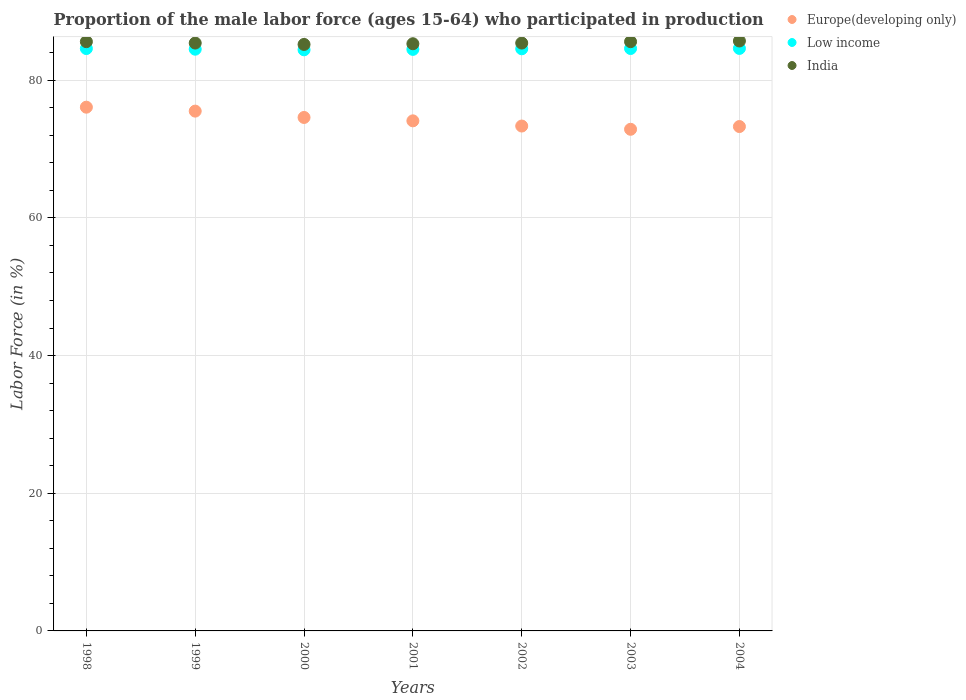How many different coloured dotlines are there?
Offer a terse response. 3. Is the number of dotlines equal to the number of legend labels?
Your answer should be very brief. Yes. What is the proportion of the male labor force who participated in production in India in 2001?
Offer a very short reply. 85.3. Across all years, what is the maximum proportion of the male labor force who participated in production in Low income?
Provide a short and direct response. 84.62. Across all years, what is the minimum proportion of the male labor force who participated in production in Low income?
Your answer should be very brief. 84.42. In which year was the proportion of the male labor force who participated in production in India maximum?
Make the answer very short. 2004. In which year was the proportion of the male labor force who participated in production in India minimum?
Offer a very short reply. 2000. What is the total proportion of the male labor force who participated in production in Low income in the graph?
Offer a terse response. 591.8. What is the difference between the proportion of the male labor force who participated in production in Low income in 2000 and that in 2004?
Your answer should be very brief. -0.2. What is the difference between the proportion of the male labor force who participated in production in India in 1999 and the proportion of the male labor force who participated in production in Low income in 2001?
Make the answer very short. 0.92. What is the average proportion of the male labor force who participated in production in Europe(developing only) per year?
Make the answer very short. 74.25. In the year 2004, what is the difference between the proportion of the male labor force who participated in production in India and proportion of the male labor force who participated in production in Europe(developing only)?
Provide a succinct answer. 12.43. In how many years, is the proportion of the male labor force who participated in production in Europe(developing only) greater than 20 %?
Offer a very short reply. 7. What is the ratio of the proportion of the male labor force who participated in production in Europe(developing only) in 1999 to that in 2003?
Make the answer very short. 1.04. Is the proportion of the male labor force who participated in production in Low income in 1998 less than that in 2001?
Your response must be concise. No. Is the difference between the proportion of the male labor force who participated in production in India in 2002 and 2003 greater than the difference between the proportion of the male labor force who participated in production in Europe(developing only) in 2002 and 2003?
Give a very brief answer. No. What is the difference between the highest and the second highest proportion of the male labor force who participated in production in India?
Make the answer very short. 0.1. What is the difference between the highest and the lowest proportion of the male labor force who participated in production in Europe(developing only)?
Your answer should be compact. 3.21. Does the proportion of the male labor force who participated in production in India monotonically increase over the years?
Your answer should be very brief. No. Is the proportion of the male labor force who participated in production in Europe(developing only) strictly greater than the proportion of the male labor force who participated in production in Low income over the years?
Your response must be concise. No. How many dotlines are there?
Offer a terse response. 3. How many years are there in the graph?
Your response must be concise. 7. Are the values on the major ticks of Y-axis written in scientific E-notation?
Offer a terse response. No. Does the graph contain any zero values?
Ensure brevity in your answer.  No. Where does the legend appear in the graph?
Your answer should be very brief. Top right. How are the legend labels stacked?
Ensure brevity in your answer.  Vertical. What is the title of the graph?
Your response must be concise. Proportion of the male labor force (ages 15-64) who participated in production. Does "Tonga" appear as one of the legend labels in the graph?
Your answer should be compact. No. What is the label or title of the X-axis?
Provide a succinct answer. Years. What is the label or title of the Y-axis?
Ensure brevity in your answer.  Labor Force (in %). What is the Labor Force (in %) in Europe(developing only) in 1998?
Offer a terse response. 76.08. What is the Labor Force (in %) of Low income in 1998?
Your response must be concise. 84.6. What is the Labor Force (in %) of India in 1998?
Your response must be concise. 85.6. What is the Labor Force (in %) in Europe(developing only) in 1999?
Ensure brevity in your answer.  75.51. What is the Labor Force (in %) of Low income in 1999?
Give a very brief answer. 84.51. What is the Labor Force (in %) in India in 1999?
Offer a very short reply. 85.4. What is the Labor Force (in %) of Europe(developing only) in 2000?
Ensure brevity in your answer.  74.59. What is the Labor Force (in %) of Low income in 2000?
Your response must be concise. 84.42. What is the Labor Force (in %) in India in 2000?
Offer a very short reply. 85.2. What is the Labor Force (in %) in Europe(developing only) in 2001?
Provide a short and direct response. 74.1. What is the Labor Force (in %) in Low income in 2001?
Make the answer very short. 84.48. What is the Labor Force (in %) of India in 2001?
Give a very brief answer. 85.3. What is the Labor Force (in %) in Europe(developing only) in 2002?
Your response must be concise. 73.34. What is the Labor Force (in %) in Low income in 2002?
Your answer should be very brief. 84.57. What is the Labor Force (in %) in India in 2002?
Your answer should be very brief. 85.4. What is the Labor Force (in %) of Europe(developing only) in 2003?
Make the answer very short. 72.87. What is the Labor Force (in %) of Low income in 2003?
Provide a succinct answer. 84.61. What is the Labor Force (in %) of India in 2003?
Offer a terse response. 85.6. What is the Labor Force (in %) of Europe(developing only) in 2004?
Your answer should be very brief. 73.27. What is the Labor Force (in %) of Low income in 2004?
Offer a terse response. 84.62. What is the Labor Force (in %) of India in 2004?
Ensure brevity in your answer.  85.7. Across all years, what is the maximum Labor Force (in %) in Europe(developing only)?
Keep it short and to the point. 76.08. Across all years, what is the maximum Labor Force (in %) of Low income?
Keep it short and to the point. 84.62. Across all years, what is the maximum Labor Force (in %) of India?
Make the answer very short. 85.7. Across all years, what is the minimum Labor Force (in %) in Europe(developing only)?
Keep it short and to the point. 72.87. Across all years, what is the minimum Labor Force (in %) of Low income?
Offer a very short reply. 84.42. Across all years, what is the minimum Labor Force (in %) in India?
Your answer should be compact. 85.2. What is the total Labor Force (in %) in Europe(developing only) in the graph?
Your answer should be very brief. 519.78. What is the total Labor Force (in %) in Low income in the graph?
Your response must be concise. 591.8. What is the total Labor Force (in %) in India in the graph?
Provide a succinct answer. 598.2. What is the difference between the Labor Force (in %) in Europe(developing only) in 1998 and that in 1999?
Ensure brevity in your answer.  0.57. What is the difference between the Labor Force (in %) in Low income in 1998 and that in 1999?
Make the answer very short. 0.09. What is the difference between the Labor Force (in %) of India in 1998 and that in 1999?
Provide a succinct answer. 0.2. What is the difference between the Labor Force (in %) of Europe(developing only) in 1998 and that in 2000?
Provide a short and direct response. 1.49. What is the difference between the Labor Force (in %) in Low income in 1998 and that in 2000?
Provide a short and direct response. 0.19. What is the difference between the Labor Force (in %) of Europe(developing only) in 1998 and that in 2001?
Offer a terse response. 1.98. What is the difference between the Labor Force (in %) of Low income in 1998 and that in 2001?
Provide a short and direct response. 0.12. What is the difference between the Labor Force (in %) in Europe(developing only) in 1998 and that in 2002?
Provide a succinct answer. 2.74. What is the difference between the Labor Force (in %) of Low income in 1998 and that in 2002?
Make the answer very short. 0.04. What is the difference between the Labor Force (in %) in India in 1998 and that in 2002?
Your answer should be compact. 0.2. What is the difference between the Labor Force (in %) of Europe(developing only) in 1998 and that in 2003?
Give a very brief answer. 3.21. What is the difference between the Labor Force (in %) in Low income in 1998 and that in 2003?
Your response must be concise. -0.01. What is the difference between the Labor Force (in %) in India in 1998 and that in 2003?
Your response must be concise. 0. What is the difference between the Labor Force (in %) of Europe(developing only) in 1998 and that in 2004?
Give a very brief answer. 2.81. What is the difference between the Labor Force (in %) in Low income in 1998 and that in 2004?
Provide a short and direct response. -0.02. What is the difference between the Labor Force (in %) of Europe(developing only) in 1999 and that in 2000?
Your answer should be compact. 0.92. What is the difference between the Labor Force (in %) in Low income in 1999 and that in 2000?
Your answer should be compact. 0.09. What is the difference between the Labor Force (in %) of Europe(developing only) in 1999 and that in 2001?
Your response must be concise. 1.41. What is the difference between the Labor Force (in %) of Low income in 1999 and that in 2001?
Keep it short and to the point. 0.03. What is the difference between the Labor Force (in %) in India in 1999 and that in 2001?
Keep it short and to the point. 0.1. What is the difference between the Labor Force (in %) of Europe(developing only) in 1999 and that in 2002?
Offer a terse response. 2.17. What is the difference between the Labor Force (in %) of Low income in 1999 and that in 2002?
Offer a terse response. -0.06. What is the difference between the Labor Force (in %) of India in 1999 and that in 2002?
Offer a very short reply. 0. What is the difference between the Labor Force (in %) of Europe(developing only) in 1999 and that in 2003?
Keep it short and to the point. 2.64. What is the difference between the Labor Force (in %) of Low income in 1999 and that in 2003?
Ensure brevity in your answer.  -0.1. What is the difference between the Labor Force (in %) of India in 1999 and that in 2003?
Provide a succinct answer. -0.2. What is the difference between the Labor Force (in %) of Europe(developing only) in 1999 and that in 2004?
Offer a very short reply. 2.24. What is the difference between the Labor Force (in %) in Low income in 1999 and that in 2004?
Make the answer very short. -0.11. What is the difference between the Labor Force (in %) in Europe(developing only) in 2000 and that in 2001?
Ensure brevity in your answer.  0.49. What is the difference between the Labor Force (in %) of Low income in 2000 and that in 2001?
Your response must be concise. -0.06. What is the difference between the Labor Force (in %) in Europe(developing only) in 2000 and that in 2002?
Provide a short and direct response. 1.25. What is the difference between the Labor Force (in %) of Low income in 2000 and that in 2002?
Provide a short and direct response. -0.15. What is the difference between the Labor Force (in %) of India in 2000 and that in 2002?
Your answer should be very brief. -0.2. What is the difference between the Labor Force (in %) of Europe(developing only) in 2000 and that in 2003?
Make the answer very short. 1.72. What is the difference between the Labor Force (in %) in Low income in 2000 and that in 2003?
Provide a succinct answer. -0.19. What is the difference between the Labor Force (in %) in India in 2000 and that in 2003?
Make the answer very short. -0.4. What is the difference between the Labor Force (in %) in Europe(developing only) in 2000 and that in 2004?
Your response must be concise. 1.32. What is the difference between the Labor Force (in %) of Low income in 2000 and that in 2004?
Offer a very short reply. -0.2. What is the difference between the Labor Force (in %) of India in 2000 and that in 2004?
Your answer should be very brief. -0.5. What is the difference between the Labor Force (in %) of Europe(developing only) in 2001 and that in 2002?
Make the answer very short. 0.75. What is the difference between the Labor Force (in %) in Low income in 2001 and that in 2002?
Make the answer very short. -0.09. What is the difference between the Labor Force (in %) in India in 2001 and that in 2002?
Ensure brevity in your answer.  -0.1. What is the difference between the Labor Force (in %) of Europe(developing only) in 2001 and that in 2003?
Give a very brief answer. 1.23. What is the difference between the Labor Force (in %) of Low income in 2001 and that in 2003?
Provide a short and direct response. -0.13. What is the difference between the Labor Force (in %) of India in 2001 and that in 2003?
Your answer should be very brief. -0.3. What is the difference between the Labor Force (in %) in Europe(developing only) in 2001 and that in 2004?
Offer a terse response. 0.83. What is the difference between the Labor Force (in %) of Low income in 2001 and that in 2004?
Provide a short and direct response. -0.14. What is the difference between the Labor Force (in %) in Europe(developing only) in 2002 and that in 2003?
Make the answer very short. 0.47. What is the difference between the Labor Force (in %) in Low income in 2002 and that in 2003?
Keep it short and to the point. -0.04. What is the difference between the Labor Force (in %) of Europe(developing only) in 2002 and that in 2004?
Your answer should be very brief. 0.07. What is the difference between the Labor Force (in %) in Low income in 2002 and that in 2004?
Your response must be concise. -0.05. What is the difference between the Labor Force (in %) of India in 2002 and that in 2004?
Provide a succinct answer. -0.3. What is the difference between the Labor Force (in %) in Europe(developing only) in 2003 and that in 2004?
Offer a terse response. -0.4. What is the difference between the Labor Force (in %) in Low income in 2003 and that in 2004?
Your answer should be compact. -0.01. What is the difference between the Labor Force (in %) of Europe(developing only) in 1998 and the Labor Force (in %) of Low income in 1999?
Provide a short and direct response. -8.42. What is the difference between the Labor Force (in %) in Europe(developing only) in 1998 and the Labor Force (in %) in India in 1999?
Make the answer very short. -9.32. What is the difference between the Labor Force (in %) in Low income in 1998 and the Labor Force (in %) in India in 1999?
Ensure brevity in your answer.  -0.8. What is the difference between the Labor Force (in %) of Europe(developing only) in 1998 and the Labor Force (in %) of Low income in 2000?
Provide a short and direct response. -8.33. What is the difference between the Labor Force (in %) of Europe(developing only) in 1998 and the Labor Force (in %) of India in 2000?
Your answer should be compact. -9.12. What is the difference between the Labor Force (in %) in Low income in 1998 and the Labor Force (in %) in India in 2000?
Make the answer very short. -0.6. What is the difference between the Labor Force (in %) in Europe(developing only) in 1998 and the Labor Force (in %) in Low income in 2001?
Provide a succinct answer. -8.4. What is the difference between the Labor Force (in %) of Europe(developing only) in 1998 and the Labor Force (in %) of India in 2001?
Provide a succinct answer. -9.22. What is the difference between the Labor Force (in %) of Low income in 1998 and the Labor Force (in %) of India in 2001?
Your response must be concise. -0.7. What is the difference between the Labor Force (in %) in Europe(developing only) in 1998 and the Labor Force (in %) in Low income in 2002?
Provide a succinct answer. -8.48. What is the difference between the Labor Force (in %) in Europe(developing only) in 1998 and the Labor Force (in %) in India in 2002?
Provide a short and direct response. -9.32. What is the difference between the Labor Force (in %) of Low income in 1998 and the Labor Force (in %) of India in 2002?
Give a very brief answer. -0.8. What is the difference between the Labor Force (in %) of Europe(developing only) in 1998 and the Labor Force (in %) of Low income in 2003?
Provide a short and direct response. -8.52. What is the difference between the Labor Force (in %) of Europe(developing only) in 1998 and the Labor Force (in %) of India in 2003?
Your answer should be compact. -9.52. What is the difference between the Labor Force (in %) in Low income in 1998 and the Labor Force (in %) in India in 2003?
Your answer should be very brief. -1. What is the difference between the Labor Force (in %) in Europe(developing only) in 1998 and the Labor Force (in %) in Low income in 2004?
Offer a very short reply. -8.54. What is the difference between the Labor Force (in %) of Europe(developing only) in 1998 and the Labor Force (in %) of India in 2004?
Keep it short and to the point. -9.62. What is the difference between the Labor Force (in %) in Low income in 1998 and the Labor Force (in %) in India in 2004?
Ensure brevity in your answer.  -1.1. What is the difference between the Labor Force (in %) of Europe(developing only) in 1999 and the Labor Force (in %) of Low income in 2000?
Your answer should be compact. -8.9. What is the difference between the Labor Force (in %) of Europe(developing only) in 1999 and the Labor Force (in %) of India in 2000?
Ensure brevity in your answer.  -9.69. What is the difference between the Labor Force (in %) of Low income in 1999 and the Labor Force (in %) of India in 2000?
Your response must be concise. -0.69. What is the difference between the Labor Force (in %) in Europe(developing only) in 1999 and the Labor Force (in %) in Low income in 2001?
Your answer should be very brief. -8.97. What is the difference between the Labor Force (in %) in Europe(developing only) in 1999 and the Labor Force (in %) in India in 2001?
Provide a succinct answer. -9.79. What is the difference between the Labor Force (in %) in Low income in 1999 and the Labor Force (in %) in India in 2001?
Offer a very short reply. -0.79. What is the difference between the Labor Force (in %) in Europe(developing only) in 1999 and the Labor Force (in %) in Low income in 2002?
Provide a short and direct response. -9.05. What is the difference between the Labor Force (in %) of Europe(developing only) in 1999 and the Labor Force (in %) of India in 2002?
Provide a succinct answer. -9.89. What is the difference between the Labor Force (in %) in Low income in 1999 and the Labor Force (in %) in India in 2002?
Your answer should be very brief. -0.89. What is the difference between the Labor Force (in %) in Europe(developing only) in 1999 and the Labor Force (in %) in Low income in 2003?
Give a very brief answer. -9.1. What is the difference between the Labor Force (in %) in Europe(developing only) in 1999 and the Labor Force (in %) in India in 2003?
Offer a very short reply. -10.09. What is the difference between the Labor Force (in %) of Low income in 1999 and the Labor Force (in %) of India in 2003?
Your answer should be very brief. -1.09. What is the difference between the Labor Force (in %) of Europe(developing only) in 1999 and the Labor Force (in %) of Low income in 2004?
Offer a very short reply. -9.11. What is the difference between the Labor Force (in %) of Europe(developing only) in 1999 and the Labor Force (in %) of India in 2004?
Provide a short and direct response. -10.19. What is the difference between the Labor Force (in %) in Low income in 1999 and the Labor Force (in %) in India in 2004?
Keep it short and to the point. -1.19. What is the difference between the Labor Force (in %) in Europe(developing only) in 2000 and the Labor Force (in %) in Low income in 2001?
Offer a terse response. -9.89. What is the difference between the Labor Force (in %) of Europe(developing only) in 2000 and the Labor Force (in %) of India in 2001?
Your response must be concise. -10.71. What is the difference between the Labor Force (in %) in Low income in 2000 and the Labor Force (in %) in India in 2001?
Make the answer very short. -0.88. What is the difference between the Labor Force (in %) of Europe(developing only) in 2000 and the Labor Force (in %) of Low income in 2002?
Keep it short and to the point. -9.98. What is the difference between the Labor Force (in %) of Europe(developing only) in 2000 and the Labor Force (in %) of India in 2002?
Give a very brief answer. -10.81. What is the difference between the Labor Force (in %) of Low income in 2000 and the Labor Force (in %) of India in 2002?
Keep it short and to the point. -0.98. What is the difference between the Labor Force (in %) of Europe(developing only) in 2000 and the Labor Force (in %) of Low income in 2003?
Ensure brevity in your answer.  -10.02. What is the difference between the Labor Force (in %) in Europe(developing only) in 2000 and the Labor Force (in %) in India in 2003?
Provide a succinct answer. -11.01. What is the difference between the Labor Force (in %) of Low income in 2000 and the Labor Force (in %) of India in 2003?
Your answer should be compact. -1.18. What is the difference between the Labor Force (in %) of Europe(developing only) in 2000 and the Labor Force (in %) of Low income in 2004?
Offer a very short reply. -10.03. What is the difference between the Labor Force (in %) of Europe(developing only) in 2000 and the Labor Force (in %) of India in 2004?
Keep it short and to the point. -11.11. What is the difference between the Labor Force (in %) in Low income in 2000 and the Labor Force (in %) in India in 2004?
Keep it short and to the point. -1.28. What is the difference between the Labor Force (in %) in Europe(developing only) in 2001 and the Labor Force (in %) in Low income in 2002?
Give a very brief answer. -10.47. What is the difference between the Labor Force (in %) in Europe(developing only) in 2001 and the Labor Force (in %) in India in 2002?
Give a very brief answer. -11.3. What is the difference between the Labor Force (in %) in Low income in 2001 and the Labor Force (in %) in India in 2002?
Your response must be concise. -0.92. What is the difference between the Labor Force (in %) of Europe(developing only) in 2001 and the Labor Force (in %) of Low income in 2003?
Provide a short and direct response. -10.51. What is the difference between the Labor Force (in %) in Europe(developing only) in 2001 and the Labor Force (in %) in India in 2003?
Ensure brevity in your answer.  -11.5. What is the difference between the Labor Force (in %) in Low income in 2001 and the Labor Force (in %) in India in 2003?
Your response must be concise. -1.12. What is the difference between the Labor Force (in %) in Europe(developing only) in 2001 and the Labor Force (in %) in Low income in 2004?
Offer a very short reply. -10.52. What is the difference between the Labor Force (in %) of Europe(developing only) in 2001 and the Labor Force (in %) of India in 2004?
Provide a short and direct response. -11.6. What is the difference between the Labor Force (in %) in Low income in 2001 and the Labor Force (in %) in India in 2004?
Your answer should be very brief. -1.22. What is the difference between the Labor Force (in %) of Europe(developing only) in 2002 and the Labor Force (in %) of Low income in 2003?
Make the answer very short. -11.26. What is the difference between the Labor Force (in %) of Europe(developing only) in 2002 and the Labor Force (in %) of India in 2003?
Keep it short and to the point. -12.26. What is the difference between the Labor Force (in %) in Low income in 2002 and the Labor Force (in %) in India in 2003?
Provide a short and direct response. -1.03. What is the difference between the Labor Force (in %) of Europe(developing only) in 2002 and the Labor Force (in %) of Low income in 2004?
Your answer should be compact. -11.28. What is the difference between the Labor Force (in %) of Europe(developing only) in 2002 and the Labor Force (in %) of India in 2004?
Your answer should be compact. -12.36. What is the difference between the Labor Force (in %) of Low income in 2002 and the Labor Force (in %) of India in 2004?
Your answer should be compact. -1.13. What is the difference between the Labor Force (in %) of Europe(developing only) in 2003 and the Labor Force (in %) of Low income in 2004?
Provide a short and direct response. -11.75. What is the difference between the Labor Force (in %) of Europe(developing only) in 2003 and the Labor Force (in %) of India in 2004?
Offer a very short reply. -12.83. What is the difference between the Labor Force (in %) in Low income in 2003 and the Labor Force (in %) in India in 2004?
Make the answer very short. -1.09. What is the average Labor Force (in %) of Europe(developing only) per year?
Provide a succinct answer. 74.25. What is the average Labor Force (in %) of Low income per year?
Offer a terse response. 84.54. What is the average Labor Force (in %) of India per year?
Your answer should be very brief. 85.46. In the year 1998, what is the difference between the Labor Force (in %) in Europe(developing only) and Labor Force (in %) in Low income?
Provide a succinct answer. -8.52. In the year 1998, what is the difference between the Labor Force (in %) of Europe(developing only) and Labor Force (in %) of India?
Offer a terse response. -9.52. In the year 1998, what is the difference between the Labor Force (in %) of Low income and Labor Force (in %) of India?
Your response must be concise. -1. In the year 1999, what is the difference between the Labor Force (in %) in Europe(developing only) and Labor Force (in %) in Low income?
Give a very brief answer. -9. In the year 1999, what is the difference between the Labor Force (in %) of Europe(developing only) and Labor Force (in %) of India?
Give a very brief answer. -9.89. In the year 1999, what is the difference between the Labor Force (in %) in Low income and Labor Force (in %) in India?
Your response must be concise. -0.89. In the year 2000, what is the difference between the Labor Force (in %) in Europe(developing only) and Labor Force (in %) in Low income?
Make the answer very short. -9.83. In the year 2000, what is the difference between the Labor Force (in %) in Europe(developing only) and Labor Force (in %) in India?
Your answer should be compact. -10.61. In the year 2000, what is the difference between the Labor Force (in %) in Low income and Labor Force (in %) in India?
Provide a short and direct response. -0.78. In the year 2001, what is the difference between the Labor Force (in %) of Europe(developing only) and Labor Force (in %) of Low income?
Your answer should be compact. -10.38. In the year 2001, what is the difference between the Labor Force (in %) in Europe(developing only) and Labor Force (in %) in India?
Provide a succinct answer. -11.2. In the year 2001, what is the difference between the Labor Force (in %) in Low income and Labor Force (in %) in India?
Your answer should be very brief. -0.82. In the year 2002, what is the difference between the Labor Force (in %) of Europe(developing only) and Labor Force (in %) of Low income?
Provide a succinct answer. -11.22. In the year 2002, what is the difference between the Labor Force (in %) in Europe(developing only) and Labor Force (in %) in India?
Offer a very short reply. -12.06. In the year 2002, what is the difference between the Labor Force (in %) in Low income and Labor Force (in %) in India?
Your response must be concise. -0.83. In the year 2003, what is the difference between the Labor Force (in %) in Europe(developing only) and Labor Force (in %) in Low income?
Your answer should be very brief. -11.73. In the year 2003, what is the difference between the Labor Force (in %) in Europe(developing only) and Labor Force (in %) in India?
Your answer should be very brief. -12.73. In the year 2003, what is the difference between the Labor Force (in %) in Low income and Labor Force (in %) in India?
Ensure brevity in your answer.  -0.99. In the year 2004, what is the difference between the Labor Force (in %) in Europe(developing only) and Labor Force (in %) in Low income?
Keep it short and to the point. -11.35. In the year 2004, what is the difference between the Labor Force (in %) of Europe(developing only) and Labor Force (in %) of India?
Make the answer very short. -12.43. In the year 2004, what is the difference between the Labor Force (in %) of Low income and Labor Force (in %) of India?
Provide a succinct answer. -1.08. What is the ratio of the Labor Force (in %) in Europe(developing only) in 1998 to that in 1999?
Ensure brevity in your answer.  1.01. What is the ratio of the Labor Force (in %) in Low income in 1998 to that in 1999?
Your answer should be very brief. 1. What is the ratio of the Labor Force (in %) in India in 1998 to that in 1999?
Ensure brevity in your answer.  1. What is the ratio of the Labor Force (in %) in Europe(developing only) in 1998 to that in 2000?
Make the answer very short. 1.02. What is the ratio of the Labor Force (in %) in Low income in 1998 to that in 2000?
Keep it short and to the point. 1. What is the ratio of the Labor Force (in %) of India in 1998 to that in 2000?
Your answer should be compact. 1. What is the ratio of the Labor Force (in %) in Europe(developing only) in 1998 to that in 2001?
Offer a terse response. 1.03. What is the ratio of the Labor Force (in %) in Low income in 1998 to that in 2001?
Ensure brevity in your answer.  1. What is the ratio of the Labor Force (in %) of Europe(developing only) in 1998 to that in 2002?
Make the answer very short. 1.04. What is the ratio of the Labor Force (in %) in Europe(developing only) in 1998 to that in 2003?
Ensure brevity in your answer.  1.04. What is the ratio of the Labor Force (in %) of Low income in 1998 to that in 2003?
Provide a short and direct response. 1. What is the ratio of the Labor Force (in %) in India in 1998 to that in 2003?
Ensure brevity in your answer.  1. What is the ratio of the Labor Force (in %) of Europe(developing only) in 1998 to that in 2004?
Your response must be concise. 1.04. What is the ratio of the Labor Force (in %) in Low income in 1998 to that in 2004?
Make the answer very short. 1. What is the ratio of the Labor Force (in %) of Europe(developing only) in 1999 to that in 2000?
Give a very brief answer. 1.01. What is the ratio of the Labor Force (in %) of Europe(developing only) in 1999 to that in 2001?
Your answer should be compact. 1.02. What is the ratio of the Labor Force (in %) in India in 1999 to that in 2001?
Make the answer very short. 1. What is the ratio of the Labor Force (in %) in Europe(developing only) in 1999 to that in 2002?
Keep it short and to the point. 1.03. What is the ratio of the Labor Force (in %) of India in 1999 to that in 2002?
Provide a succinct answer. 1. What is the ratio of the Labor Force (in %) of Europe(developing only) in 1999 to that in 2003?
Offer a very short reply. 1.04. What is the ratio of the Labor Force (in %) in India in 1999 to that in 2003?
Your answer should be compact. 1. What is the ratio of the Labor Force (in %) of Europe(developing only) in 1999 to that in 2004?
Offer a very short reply. 1.03. What is the ratio of the Labor Force (in %) in Europe(developing only) in 2000 to that in 2001?
Keep it short and to the point. 1.01. What is the ratio of the Labor Force (in %) of Europe(developing only) in 2000 to that in 2002?
Your answer should be compact. 1.02. What is the ratio of the Labor Force (in %) of Low income in 2000 to that in 2002?
Make the answer very short. 1. What is the ratio of the Labor Force (in %) in India in 2000 to that in 2002?
Your response must be concise. 1. What is the ratio of the Labor Force (in %) in Europe(developing only) in 2000 to that in 2003?
Keep it short and to the point. 1.02. What is the ratio of the Labor Force (in %) in India in 2000 to that in 2003?
Your answer should be very brief. 1. What is the ratio of the Labor Force (in %) in Europe(developing only) in 2001 to that in 2002?
Your response must be concise. 1.01. What is the ratio of the Labor Force (in %) of India in 2001 to that in 2002?
Provide a short and direct response. 1. What is the ratio of the Labor Force (in %) in Europe(developing only) in 2001 to that in 2003?
Ensure brevity in your answer.  1.02. What is the ratio of the Labor Force (in %) of Low income in 2001 to that in 2003?
Your answer should be very brief. 1. What is the ratio of the Labor Force (in %) in India in 2001 to that in 2003?
Offer a terse response. 1. What is the ratio of the Labor Force (in %) in Europe(developing only) in 2001 to that in 2004?
Provide a short and direct response. 1.01. What is the ratio of the Labor Force (in %) in Low income in 2001 to that in 2004?
Your answer should be compact. 1. What is the ratio of the Labor Force (in %) in Europe(developing only) in 2002 to that in 2003?
Your response must be concise. 1.01. What is the ratio of the Labor Force (in %) in Low income in 2002 to that in 2003?
Your response must be concise. 1. What is the ratio of the Labor Force (in %) of Low income in 2002 to that in 2004?
Ensure brevity in your answer.  1. What is the ratio of the Labor Force (in %) in India in 2002 to that in 2004?
Offer a terse response. 1. What is the difference between the highest and the second highest Labor Force (in %) in Europe(developing only)?
Offer a very short reply. 0.57. What is the difference between the highest and the second highest Labor Force (in %) of Low income?
Offer a terse response. 0.01. What is the difference between the highest and the lowest Labor Force (in %) in Europe(developing only)?
Offer a terse response. 3.21. What is the difference between the highest and the lowest Labor Force (in %) of Low income?
Offer a terse response. 0.2. 